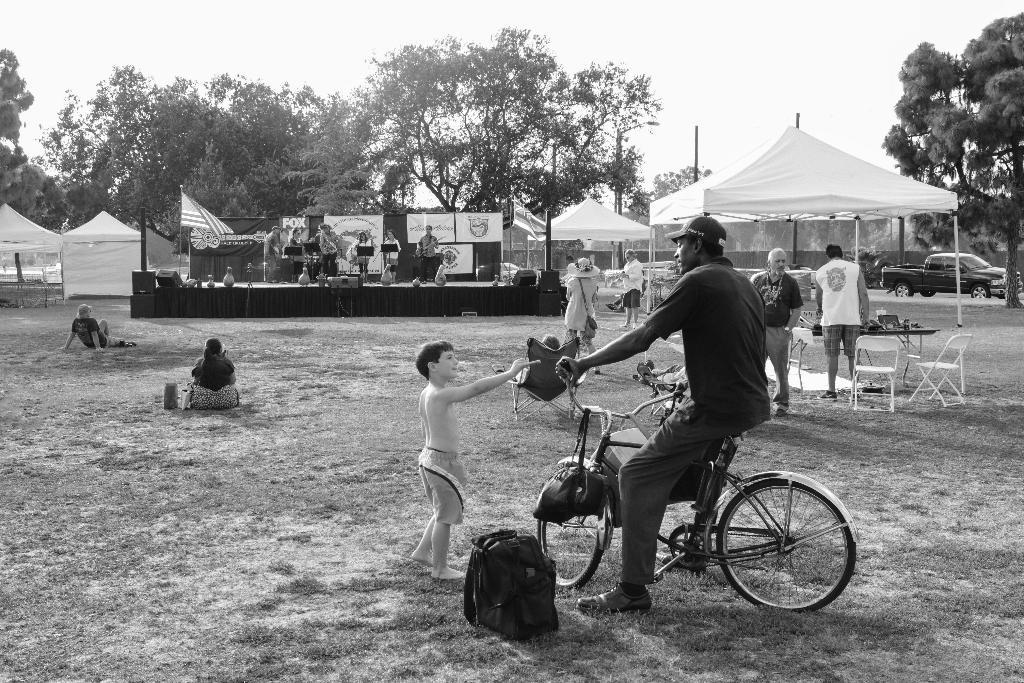What is the man doing in the image? The man is sitting on a cycle. What is located beside the cycle? There is a bag beside the cycle. What type of natural environment is visible in the image? There are trees in the image. What is visible in the background of the image? The sky is visible in the image. Reasoning: Let's think step by step by step in order to produce the conversation. We start by identifying the main subject in the image, which is the man sitting on a cycle. Then, we expand the conversation to include other items that are also visible, such as the bag beside the cycle, the trees, and the sky. Each question is designed to elicit a specific detail about the image that is known from the provided facts. Absurd Question/Answer: Can you see a tiger walking behind the trees in the image? There is no tiger present in the image; only the man, cycle, bag, trees, and sky are visible. What type of things can be seen hanging from the trees in the image? There are no things hanging from the trees in the image; only the man, cycle, bag, trees, and sky are visible. 